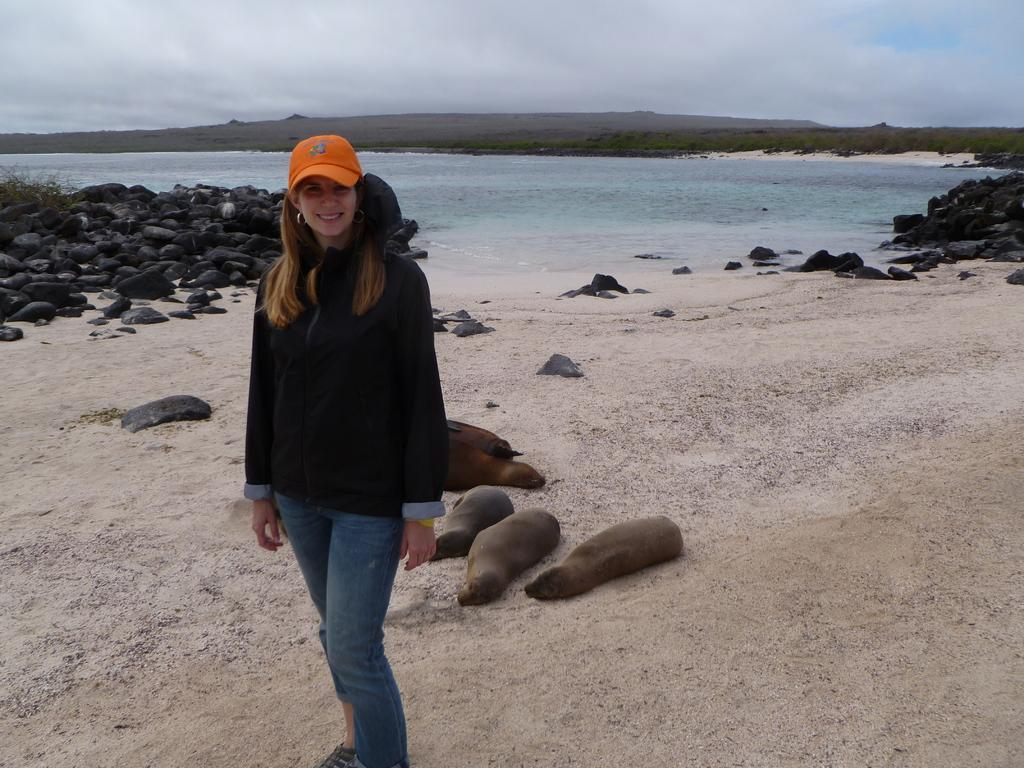What can be seen in the image related to a person? There is a person in the image. What is the person wearing on their head? The person is wearing an orange cap. What type of clothing is the person wearing on their upper body? The person is wearing a black t-shirt. What type of natural elements are present in the image? There are stones, plants, and water visible in the image. What type of title is written on the tent in the image? There is no tent present in the image, so there is no title to be read. 